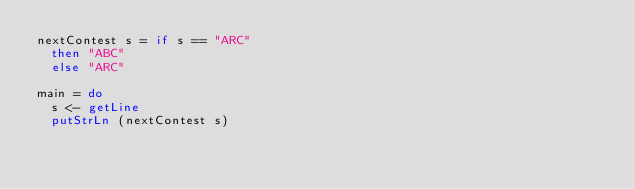Convert code to text. <code><loc_0><loc_0><loc_500><loc_500><_Haskell_>nextContest s = if s == "ARC"
  then "ABC"
  else "ARC"

main = do
  s <- getLine
  putStrLn (nextContest s)</code> 